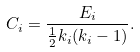<formula> <loc_0><loc_0><loc_500><loc_500>C _ { i } = \frac { E _ { i } } { \frac { 1 } { 2 } k _ { i } ( k _ { i } - 1 ) } .</formula> 